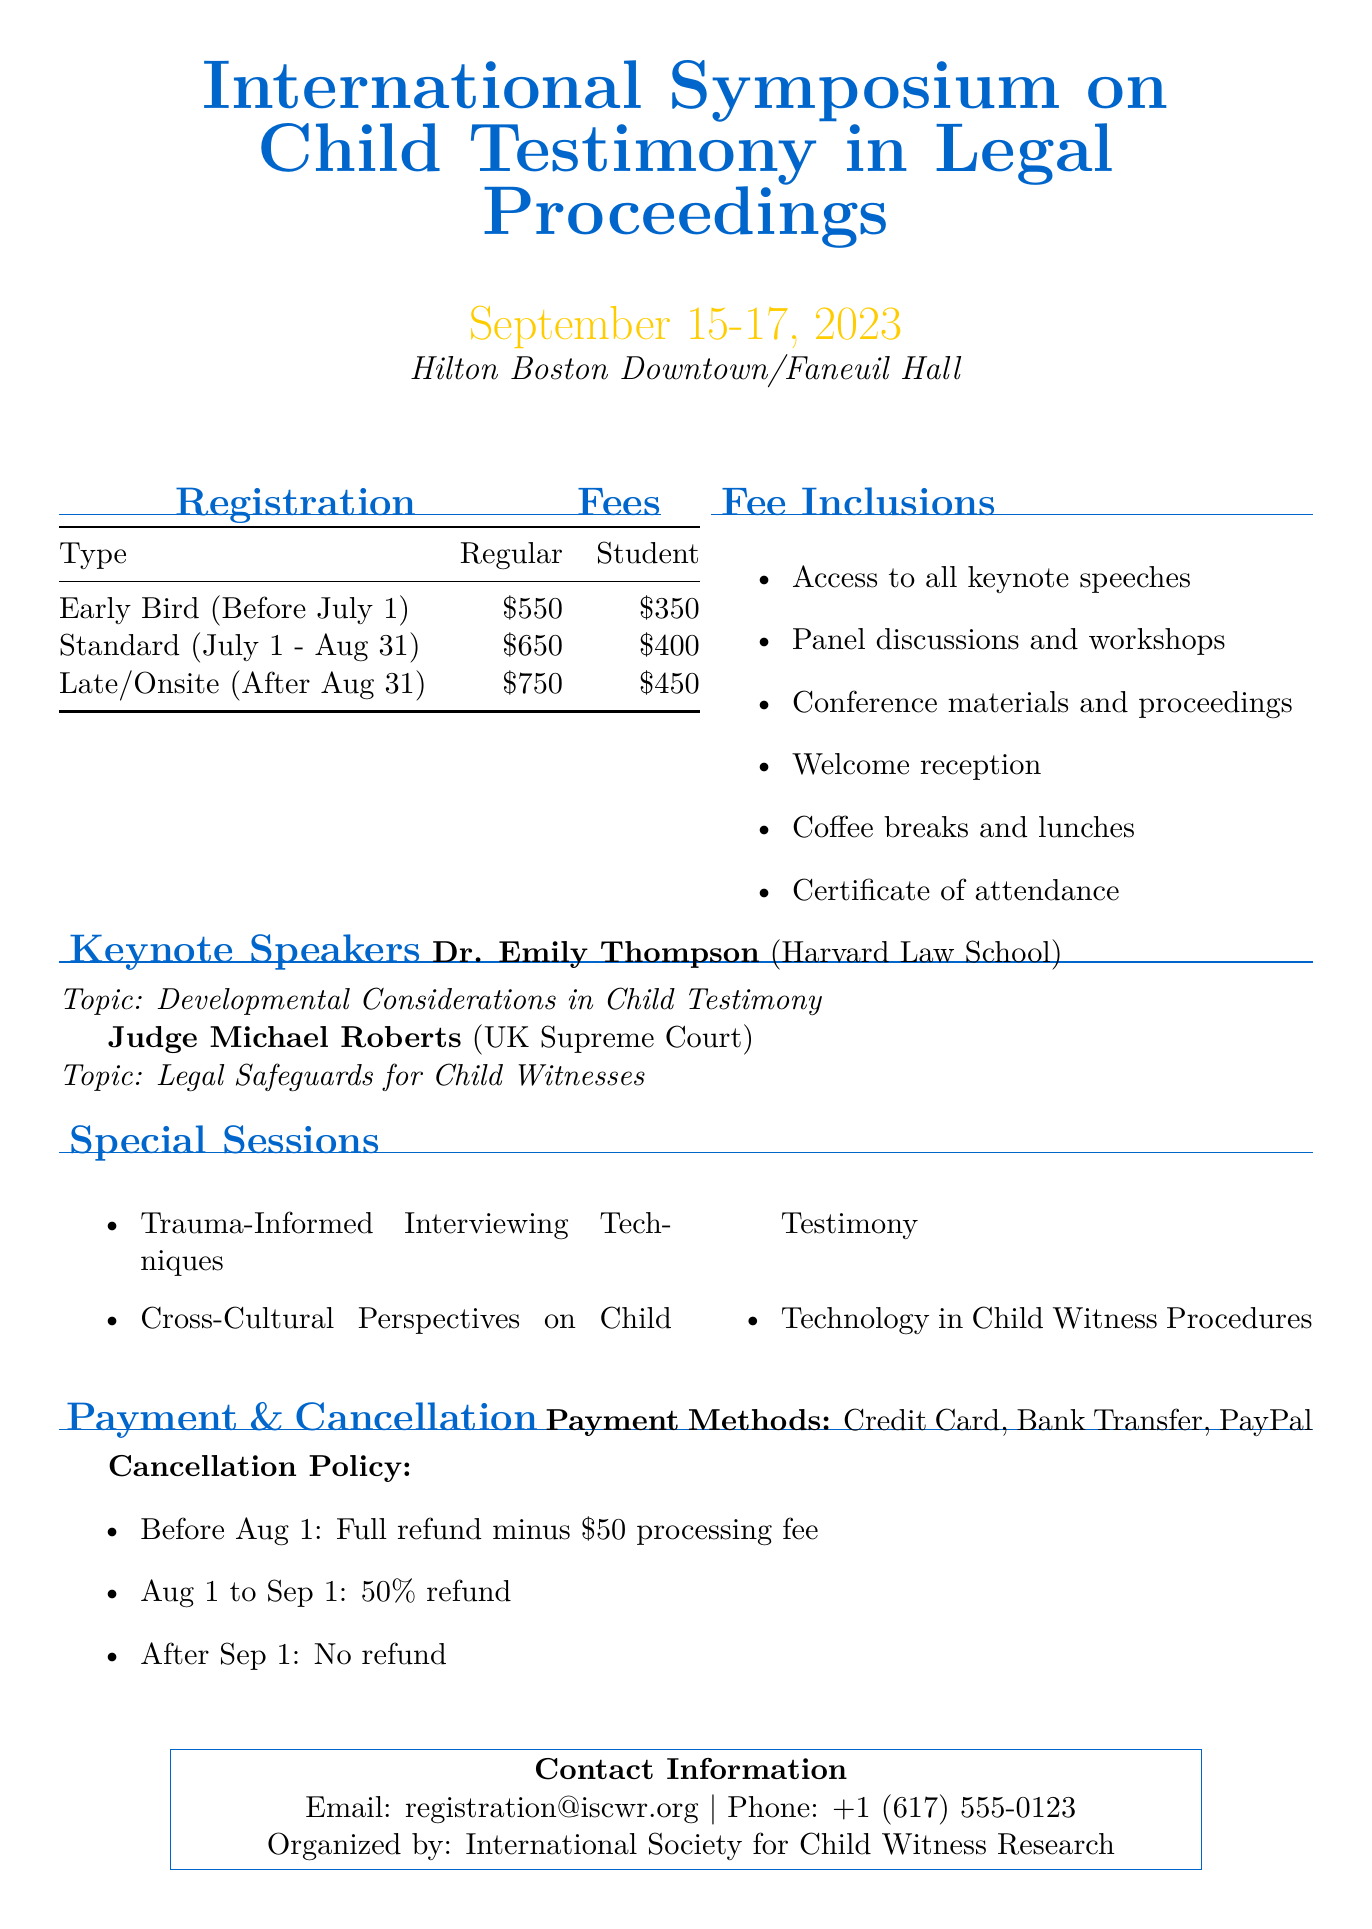what is the event name? The event name is found in the title of the document, which specifies the focus of the symposium.
Answer: International Symposium on Child Testimony in Legal Proceedings when is the early bird registration deadline? The early bird registration deadline is mentioned in the registration fee details.
Answer: July 1 how much is the regular registration fee for late onsite registration? The regular registration fee for late onsite registration is stated in the registration fee table.
Answer: 750 who is a keynote speaker from Harvard Law School? The document lists the keynote speakers along with their affiliations.
Answer: Dr. Emily Thompson what is included in the registration fee? The inclusions in the fee are provided in a bullet list, highlighting what participants receive.
Answer: Access to all keynote speeches what refund is available if cancellation occurs on August 15? The cancellation policy outlines the refunds based on timing, and August 15 falls into one of those categories.
Answer: 50% refund list a payment method mentioned in the document. The document specifies various payment methods that can be used for registration.
Answer: Credit Card what is the contact email for registration inquiries? The contact information section provides an email address for inquiries related to the event.
Answer: registration@iscwr.org name one special session topic. The special sessions are outlined in the document, presenting various relevant topics.
Answer: Trauma-Informed Interviewing Techniques 